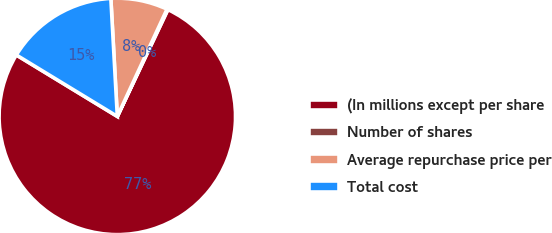Convert chart. <chart><loc_0><loc_0><loc_500><loc_500><pie_chart><fcel>(In millions except per share<fcel>Number of shares<fcel>Average repurchase price per<fcel>Total cost<nl><fcel>76.66%<fcel>0.13%<fcel>7.78%<fcel>15.43%<nl></chart> 